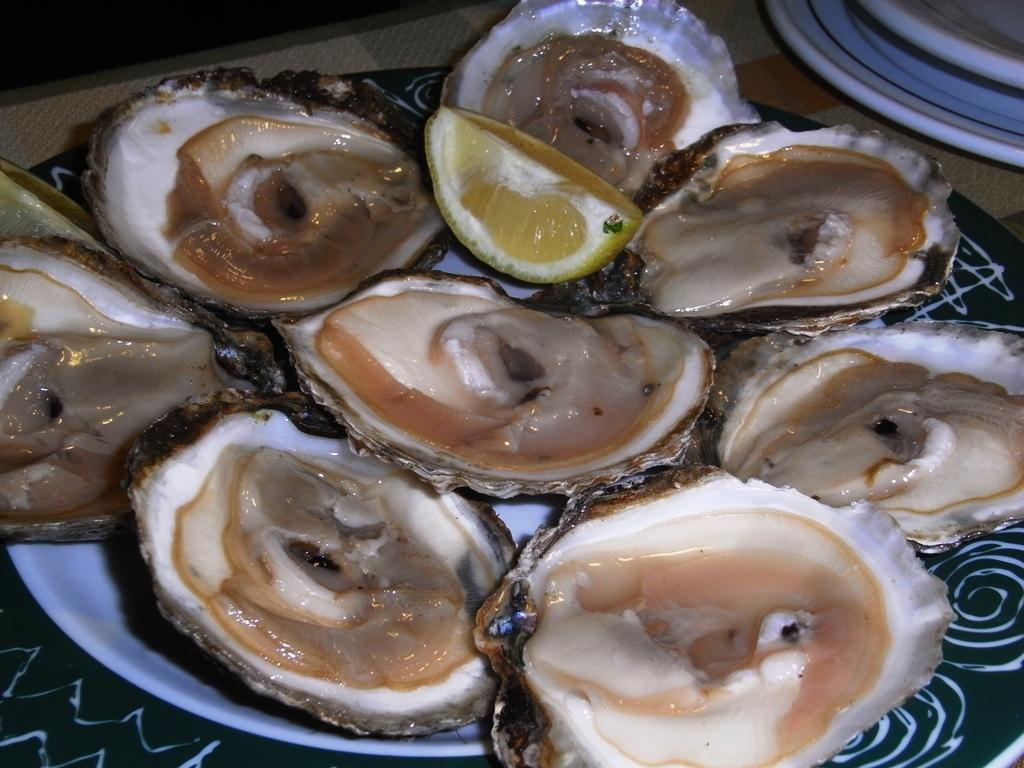What type of seafood can be seen in the image? There are mussels in shells in the image. What is placed on the plate beside the mussels? There is a piece of lemon in a plate in the image. Where is the plate with the lemon located? The plate with the lemon is placed on a surface. Are there any other plates visible in the image? Yes, there are additional plates beside the plate with the lemon. What type of chalk is being used to draw on the peace sign in the image? There is no chalk or peace sign present in the image; it features mussels in shells, a plate with a piece of lemon, and additional plates. 